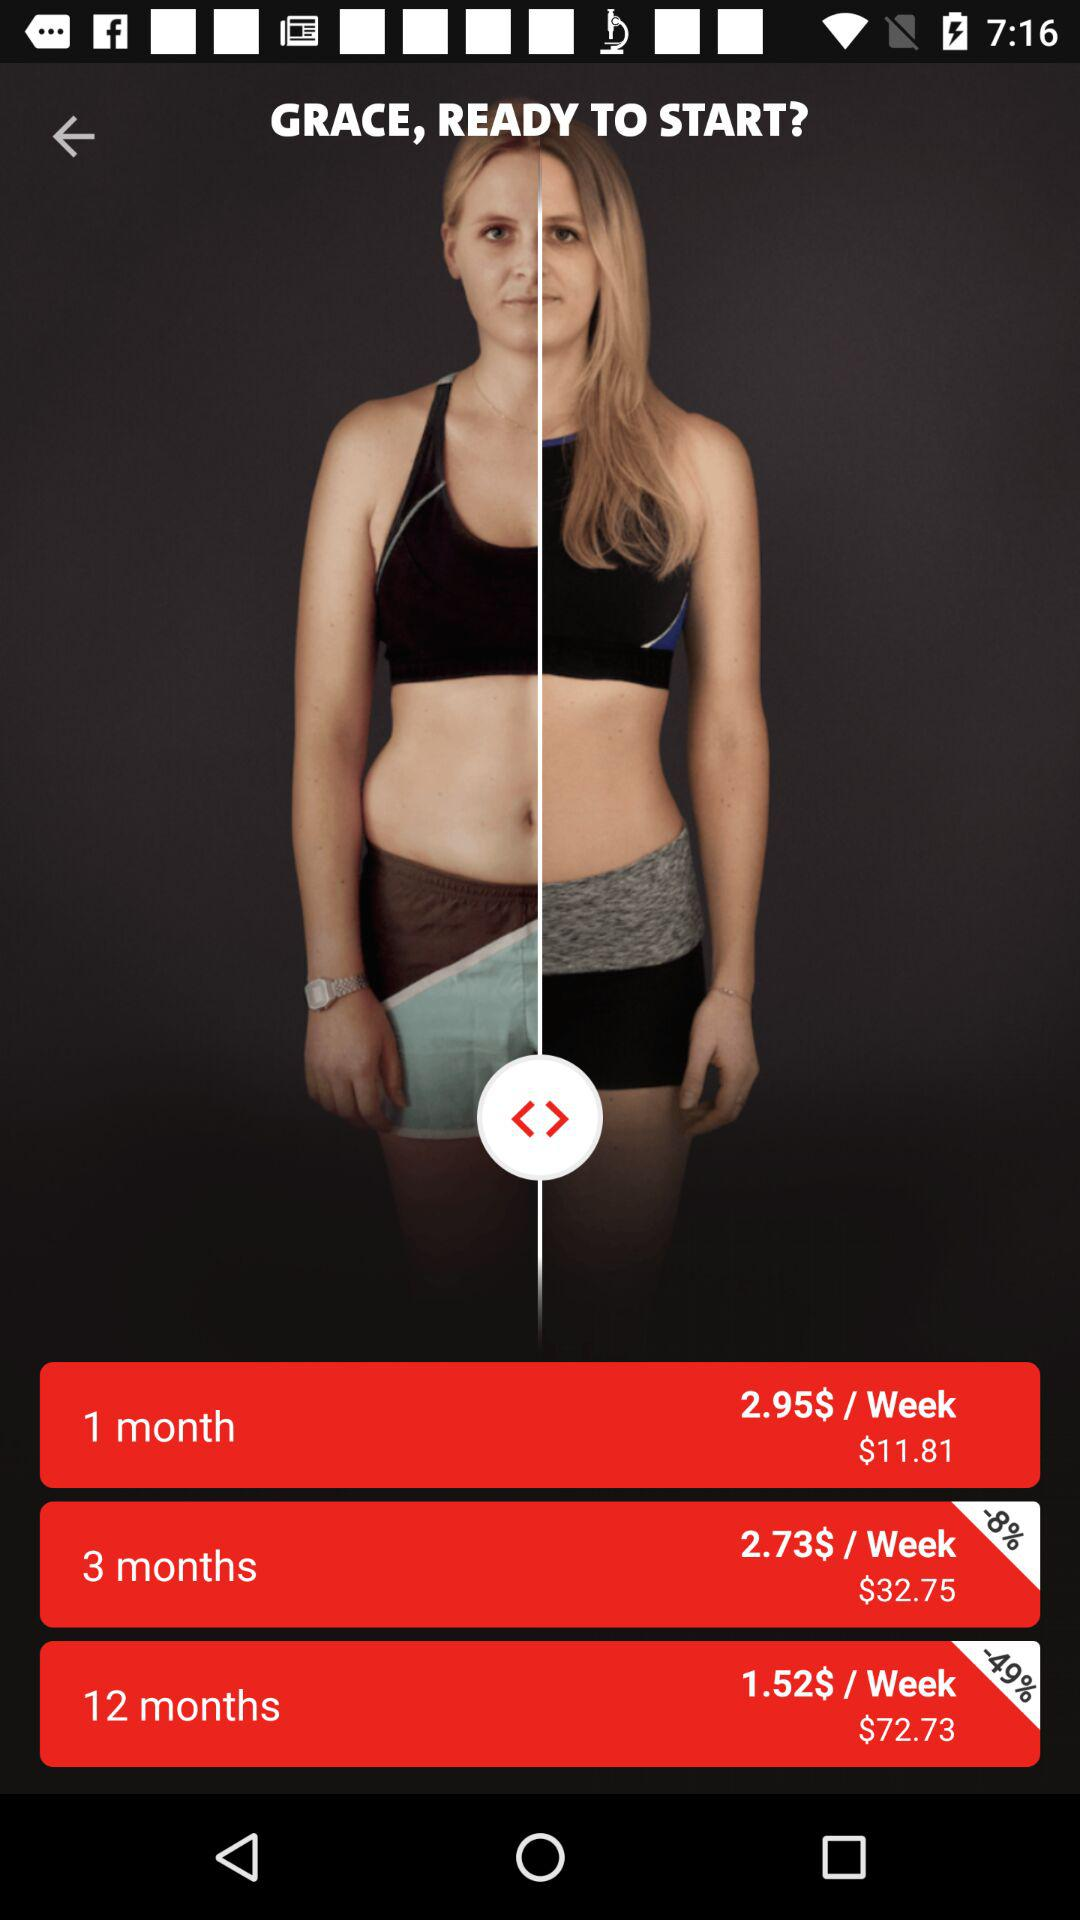What is the cost of the "12 months" plan per week? The cost of the "12 months" plan per week is $1.52. 